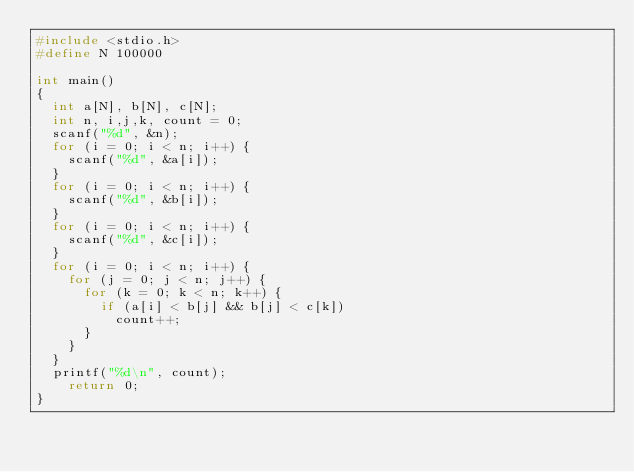<code> <loc_0><loc_0><loc_500><loc_500><_C_>#include <stdio.h>
#define N 100000

int main()
{
	int a[N], b[N], c[N];
	int n, i,j,k, count = 0;
	scanf("%d", &n);
	for (i = 0; i < n; i++) {
		scanf("%d", &a[i]);
	}
	for (i = 0; i < n; i++) {
		scanf("%d", &b[i]);
	}
	for (i = 0; i < n; i++) {
		scanf("%d", &c[i]);
	}
	for (i = 0; i < n; i++) {
		for (j = 0; j < n; j++) {
			for (k = 0; k < n; k++) {
				if (a[i] < b[j] && b[j] < c[k])
					count++;
			}
		}
	}
	printf("%d\n", count);
    return 0;
}
</code> 